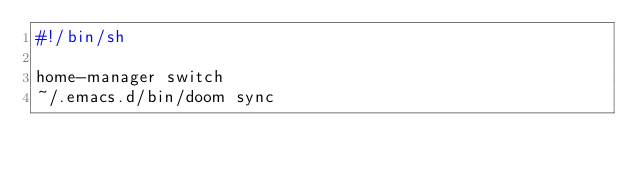<code> <loc_0><loc_0><loc_500><loc_500><_Bash_>#!/bin/sh

home-manager switch
~/.emacs.d/bin/doom sync
</code> 